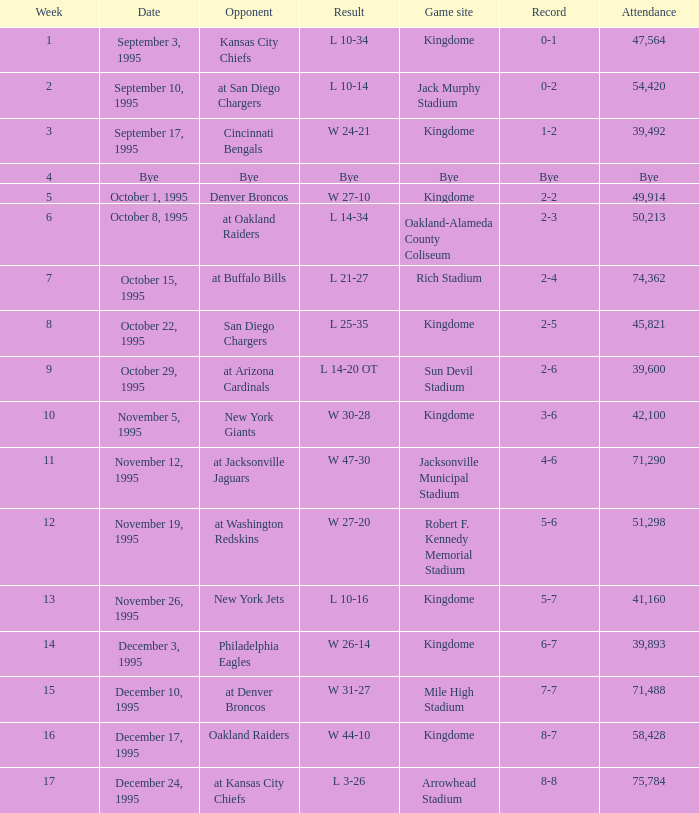Who was the opponent when the Seattle Seahawks had a record of 0-1? Kansas City Chiefs. 